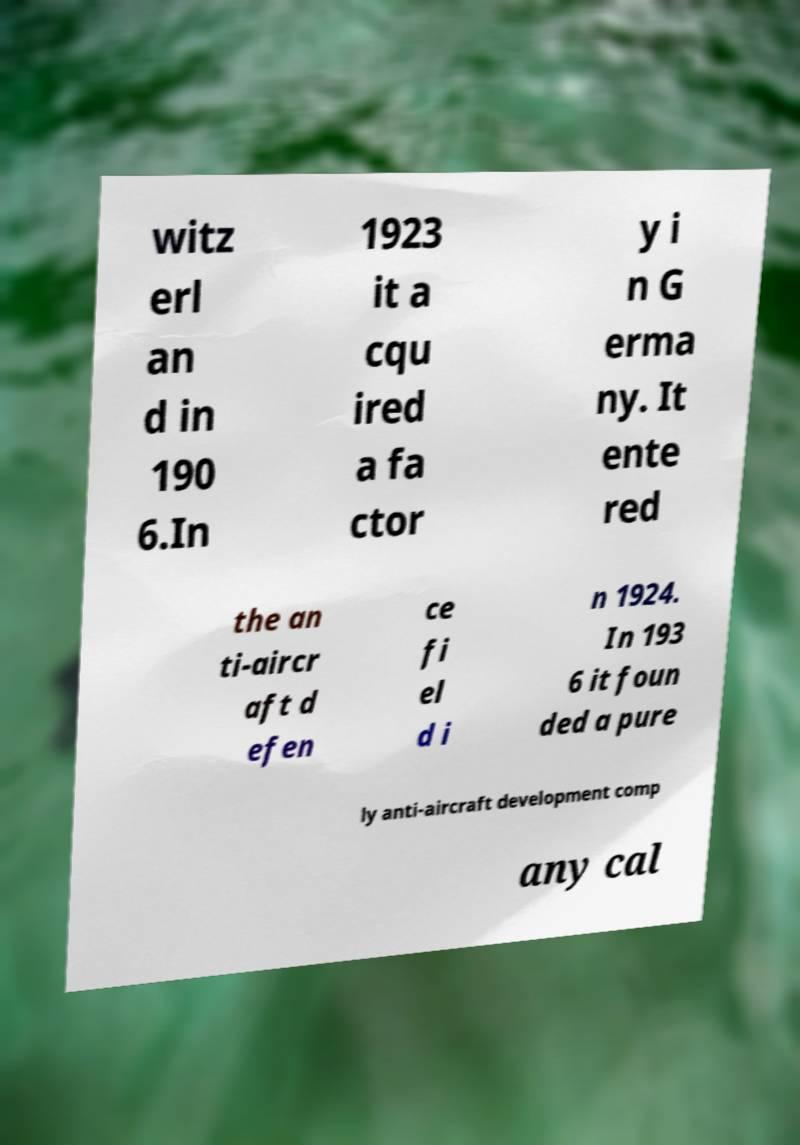Please read and relay the text visible in this image. What does it say? witz erl an d in 190 6.In 1923 it a cqu ired a fa ctor y i n G erma ny. It ente red the an ti-aircr aft d efen ce fi el d i n 1924. In 193 6 it foun ded a pure ly anti-aircraft development comp any cal 